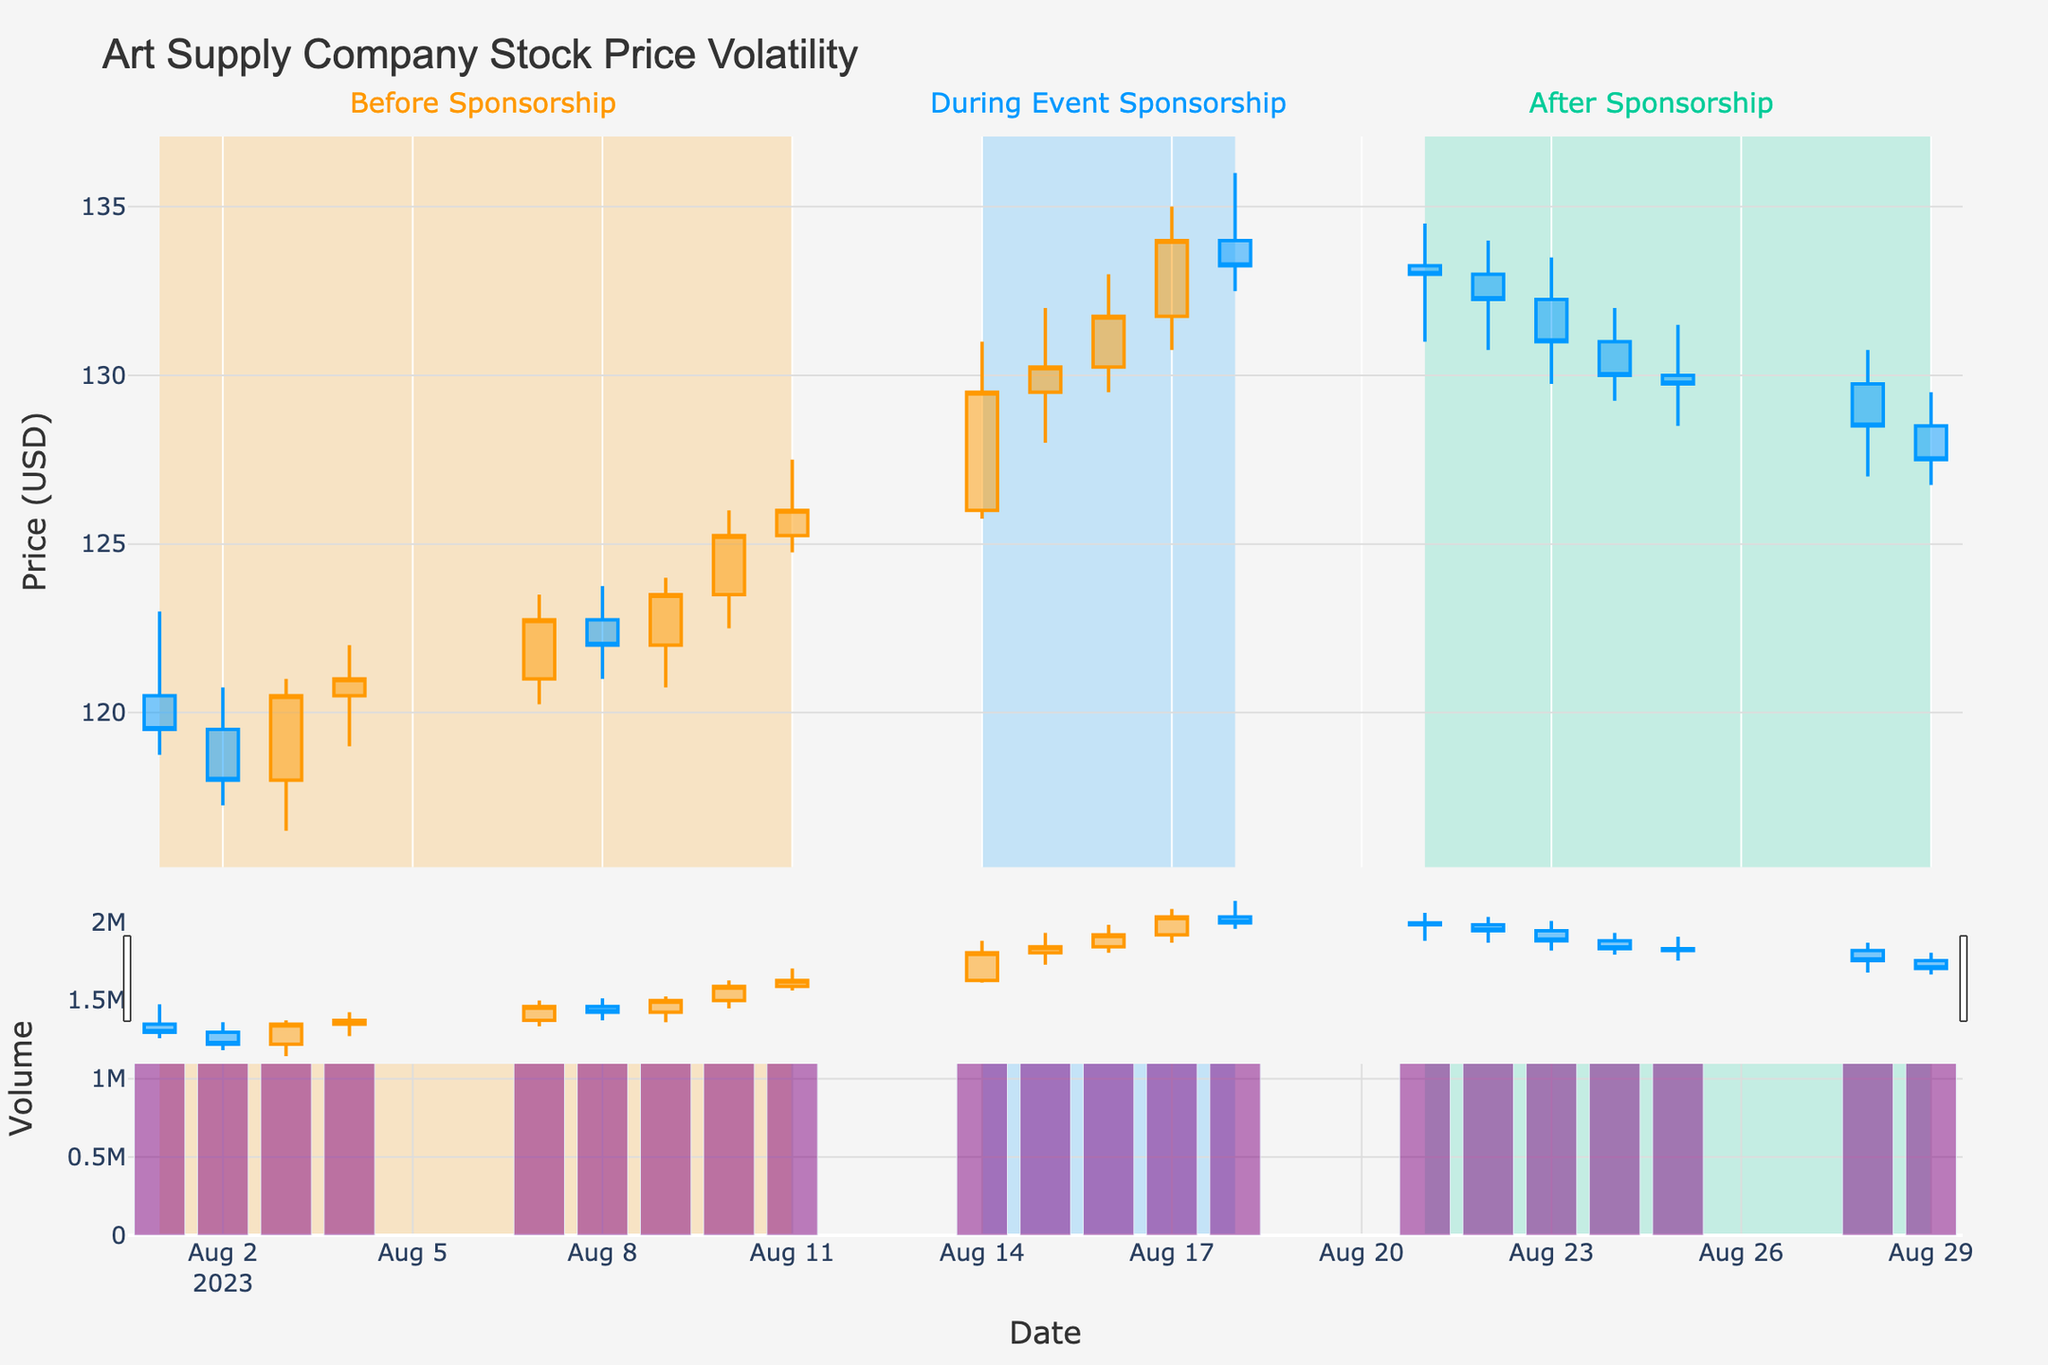What is the title of the figure? The title is written at the top of the figure in a larger font size than the rest of the text. It provides a summary of what the figure is about. The title in this case is: "Art Supply Company Stock Price Volatility".
Answer: Art Supply Company Stock Price Volatility What time period does the figure cover? The x-axis shows the dates covered by the figure. By examining the first and last dates on the x-axis, we can determine the time period. In this case, the period starts on "2023-08-01" and ends on "2023-08-29".
Answer: 2023-08-01 to 2023-08-29 How does the stock price change during the event sponsorship? The event sponsorship period is shaded differently with annotations. By looking at the candlestick patterns within this shaded region, we see that the stock price increases from around $126.00 on 2023-08-14 to around $133.25 on 2023-08-18.
Answer: Increased from around $126.00 to $133.25 What is the color of the volume bars in the plot? The color of the elements can be determined visually. The volume bars in this figure are colored in a shade of purple.
Answer: Purple Which date had the highest stock volume and what was the volume? The volume can be identified in the bar chart segment beneath the candlestick chart. By identifying the tallest bar, we see it on the date 2023-08-17 with a volume of 1,900,000.
Answer: 2023-08-17 with 1,900,000 Compare the general stock price trend before and after the sponsorship. The candlestick patterns before the sponsorship (starting from 2023-08-01 to 2023-08-11) show a gradual increase. After the sponsorship event (2023-08-21 onwards), the stock price generally trends downwards.
Answer: Gradual increase before, began to decrease after How many days experienced higher closing prices compared to their opening prices before the sponsorship? By observing the candlestick patterns, a higher closing price is indicated by a green candle. Before the sponsorship (up to 2023-08-11), we see that 7 days (2023-08-01, 2023-08-03, 2023-08-04, 2023-08-07, 2023-08-09, 2023-08-10, and 2023-08-11) had higher closing prices compared to their opening prices.
Answer: 7 days Did the highest closing price occur before, during, or after the event sponsorship? The highest closing price can be found by looking at the topmost point of any candlestick's closing position. This happens at $134.00 on 2023-08-17, which is during the event sponsorship period.
Answer: During the event sponsorship What was the closing price on the last day of the time period covered by the figure, and how does it compare to the closing price on the first day? By identifying the candlestick for the last day (2023-08-29), the closing price is $127.50. The first day's closing price (2023-08-01) is $119.50. To find the difference: $127.50 - $119.50 = $8.00 increase.
Answer: $127.50, increased by $8.00 What was the largest single-day swing in stock price, and when did it occur? The single-day swing in stock price is the difference between the highest and lowest prices for a day. The largest swing is observed on 2023-08-14 (During Sponsorship), where the stock price ranged from $125.75 to $131.00. The difference is $131.00 - $125.75 = $5.25.
Answer: $5.25 on 2023-08-14 